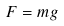Convert formula to latex. <formula><loc_0><loc_0><loc_500><loc_500>F = m g</formula> 